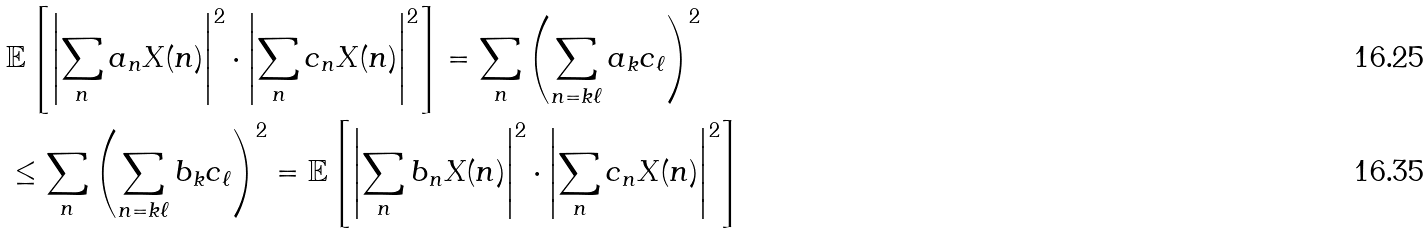Convert formula to latex. <formula><loc_0><loc_0><loc_500><loc_500>& \mathbb { E } \left [ \left | \sum _ { n } a _ { n } X ( n ) \right | ^ { 2 } \cdot \left | \sum _ { n } c _ { n } X ( n ) \right | ^ { 2 } \right ] = \sum _ { n } \left ( \sum _ { n = k \ell } a _ { k } c _ { \ell } \right ) ^ { 2 } \\ & \leq \sum _ { n } \left ( \sum _ { n = k \ell } b _ { k } c _ { \ell } \right ) ^ { 2 } = \mathbb { E } \left [ \left | \sum _ { n } b _ { n } X ( n ) \right | ^ { 2 } \cdot \left | \sum _ { n } c _ { n } X ( n ) \right | ^ { 2 } \right ]</formula> 